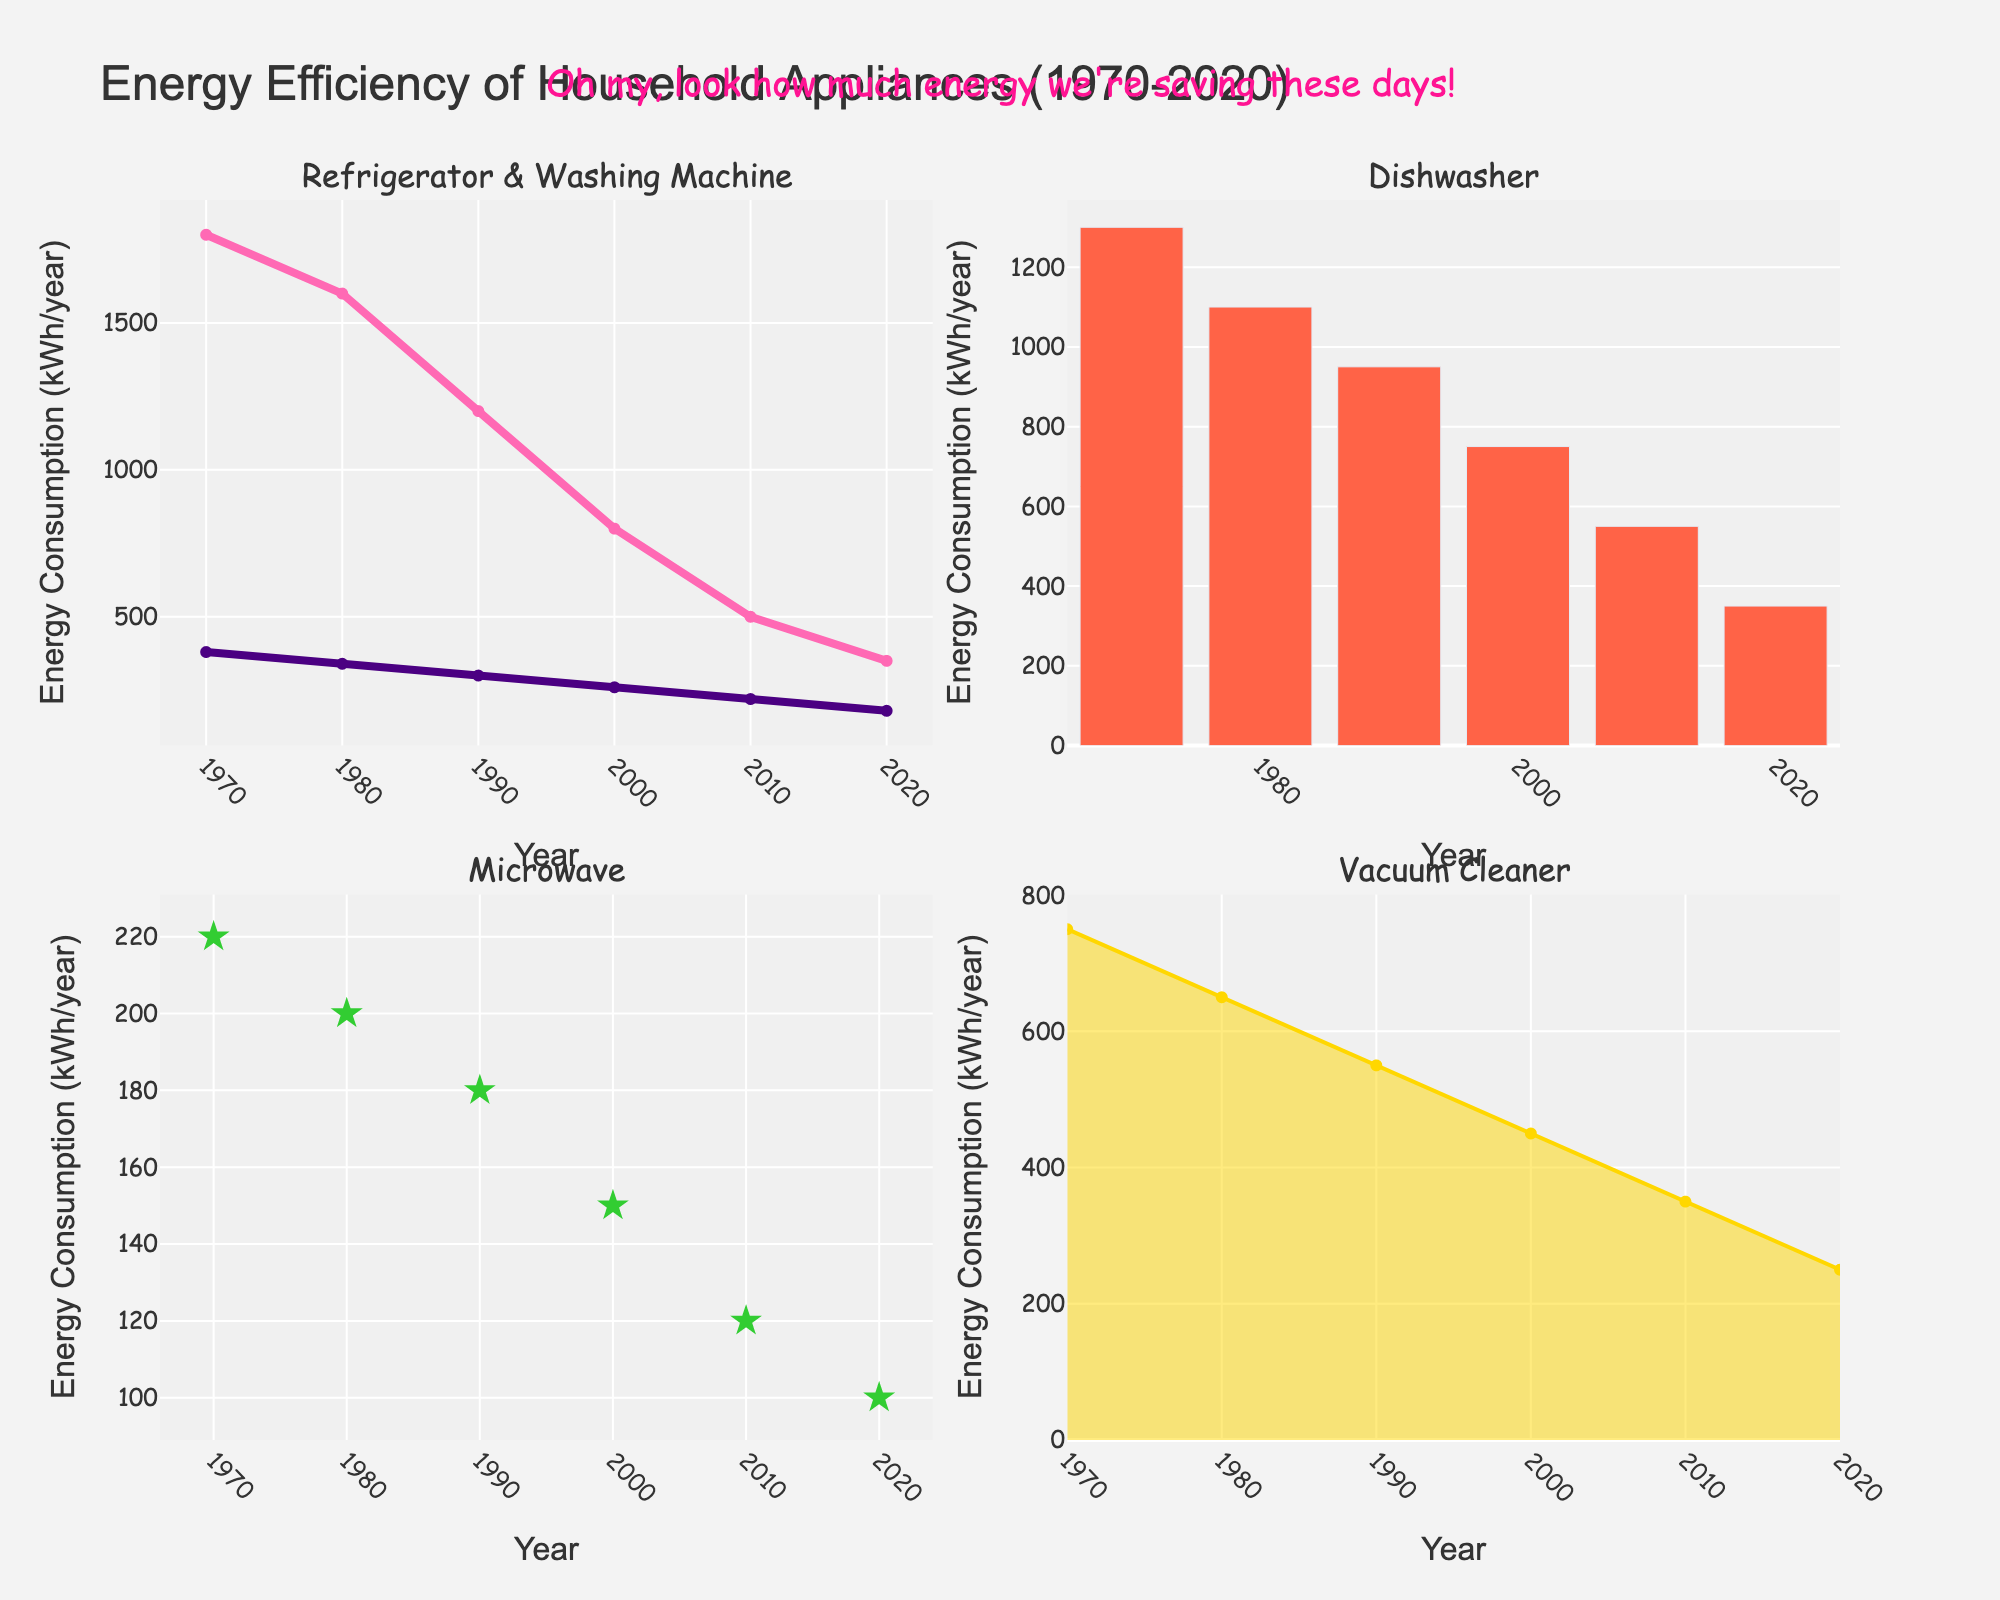What's the media type with the highest revenue percentage from original content? Locate the subplots showing the higher bar for original content. Find that "Podcasts" has the highest original content revenue at 80%.
Answer: Podcasts Which media type generates more revenue from adapted content, Anime or TV Shows? Compare the revenue percentages for adapted content in subplots of Anime and TV Shows. Anime has 55%, whereas TV Shows have 45%. Therefore, Anime generates more revenue from adapted content.
Answer: Anime How much more revenue do Broadway Shows generate from adapted content compared to original content? Identify the revenue percentages for Broadway Shows (30% for original, 70% for adapted). Subtract the original content revenue from the adapted content revenue, resulting in a difference of 40%.
Answer: 40% Which media type has an equal revenue share between original and adapted content? Check the subplots for equal bar heights. The graph for "Graphic Novels" shows both original and adapted content revenues at 50%.
Answer: Graphic Novels Is the revenue from original content in movies greater than, less than, or equal to the revenue from adapted content in Web Series? Compare the revenue percentages, Movie (40% original), Web Series (25% adapted). 40% is greater than 25%.
Answer: Greater than What is the combined revenue percentage from original content for Books and Video Games? Look at the revenue percentages for Books (65%) and Video Games (70%). Add these percentages: 65% + 70% = 135%.
Answer: 135% What's the difference in revenue percentage between adapted and original content for Comic Books? Find the revenue percentages for Comic Books (60% original, 40% adapted). The difference is 60% - 40% = 20%.
Answer: 20% Which two media types have the most significant difference in revenue percentage between adapted and original content? Locate the subplots with the widest bar differences. Broadway Shows have the most significant gap at 40%, compared to others.
Answer: Broadway Shows Does the revenue from adapted content exceed the revenue from original content for Anime? Check the Anime subplot. 55% adapted versus 45% original. Adapted content revenue exceeds original content.
Answer: Yes 